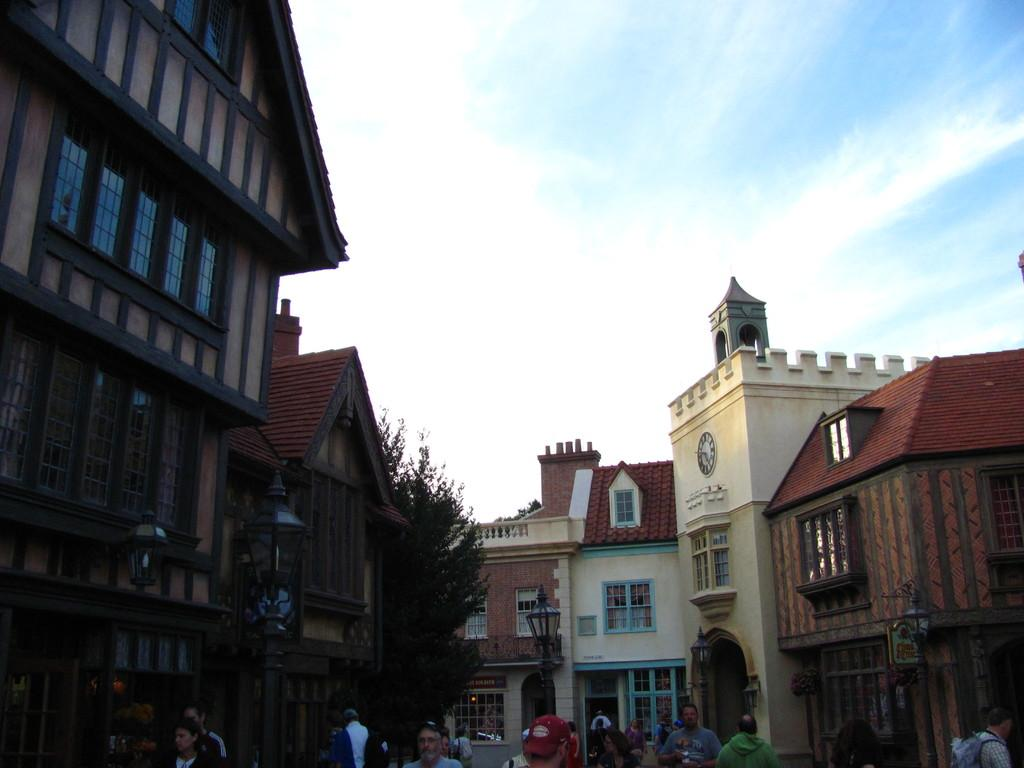What can be seen in the foreground of the image? There are people in the foreground of the image. What type of structures are present in the image? There are buildings in the image. What type of vegetation is visible in the image? There is a tree in the image. What is visible at the top of the image? The sky is visible at the top of the image. What type of soup is being served in the image? There is no soup present in the image. Can you tell me the scale of the buildings in the image? The provided facts do not include information about the scale of the buildings, so it cannot be determined from the image. 